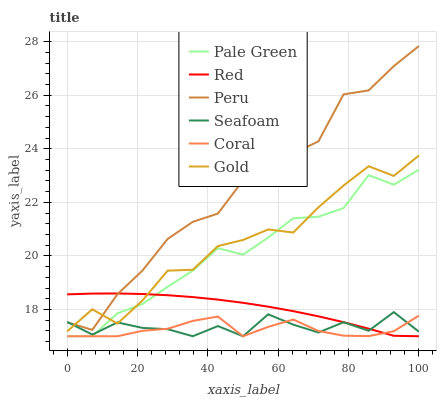Does Coral have the minimum area under the curve?
Answer yes or no. Yes. Does Peru have the maximum area under the curve?
Answer yes or no. Yes. Does Seafoam have the minimum area under the curve?
Answer yes or no. No. Does Seafoam have the maximum area under the curve?
Answer yes or no. No. Is Red the smoothest?
Answer yes or no. Yes. Is Gold the roughest?
Answer yes or no. Yes. Is Coral the smoothest?
Answer yes or no. No. Is Coral the roughest?
Answer yes or no. No. Does Coral have the lowest value?
Answer yes or no. Yes. Does Peru have the lowest value?
Answer yes or no. No. Does Peru have the highest value?
Answer yes or no. Yes. Does Seafoam have the highest value?
Answer yes or no. No. Is Coral less than Gold?
Answer yes or no. Yes. Is Peru greater than Pale Green?
Answer yes or no. Yes. Does Coral intersect Pale Green?
Answer yes or no. Yes. Is Coral less than Pale Green?
Answer yes or no. No. Is Coral greater than Pale Green?
Answer yes or no. No. Does Coral intersect Gold?
Answer yes or no. No. 